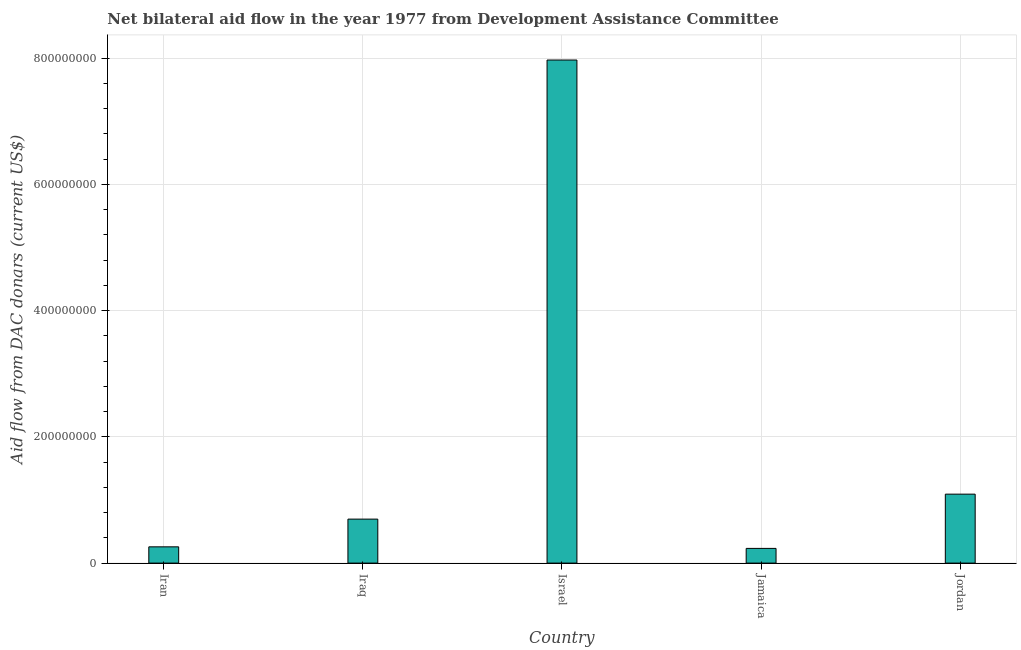Does the graph contain any zero values?
Ensure brevity in your answer.  No. What is the title of the graph?
Your response must be concise. Net bilateral aid flow in the year 1977 from Development Assistance Committee. What is the label or title of the X-axis?
Give a very brief answer. Country. What is the label or title of the Y-axis?
Your answer should be compact. Aid flow from DAC donars (current US$). What is the net bilateral aid flows from dac donors in Iran?
Ensure brevity in your answer.  2.58e+07. Across all countries, what is the maximum net bilateral aid flows from dac donors?
Offer a terse response. 7.97e+08. Across all countries, what is the minimum net bilateral aid flows from dac donors?
Ensure brevity in your answer.  2.33e+07. In which country was the net bilateral aid flows from dac donors maximum?
Offer a terse response. Israel. In which country was the net bilateral aid flows from dac donors minimum?
Provide a short and direct response. Jamaica. What is the sum of the net bilateral aid flows from dac donors?
Make the answer very short. 1.02e+09. What is the difference between the net bilateral aid flows from dac donors in Jamaica and Jordan?
Your answer should be very brief. -8.59e+07. What is the average net bilateral aid flows from dac donors per country?
Offer a terse response. 2.05e+08. What is the median net bilateral aid flows from dac donors?
Provide a succinct answer. 6.97e+07. What is the ratio of the net bilateral aid flows from dac donors in Iraq to that in Jordan?
Provide a short and direct response. 0.64. Is the difference between the net bilateral aid flows from dac donors in Iran and Jamaica greater than the difference between any two countries?
Your answer should be compact. No. What is the difference between the highest and the second highest net bilateral aid flows from dac donors?
Give a very brief answer. 6.88e+08. Is the sum of the net bilateral aid flows from dac donors in Iran and Iraq greater than the maximum net bilateral aid flows from dac donors across all countries?
Provide a short and direct response. No. What is the difference between the highest and the lowest net bilateral aid flows from dac donors?
Keep it short and to the point. 7.74e+08. In how many countries, is the net bilateral aid flows from dac donors greater than the average net bilateral aid flows from dac donors taken over all countries?
Your answer should be very brief. 1. How many countries are there in the graph?
Give a very brief answer. 5. What is the Aid flow from DAC donars (current US$) in Iran?
Make the answer very short. 2.58e+07. What is the Aid flow from DAC donars (current US$) in Iraq?
Your response must be concise. 6.97e+07. What is the Aid flow from DAC donars (current US$) in Israel?
Give a very brief answer. 7.97e+08. What is the Aid flow from DAC donars (current US$) of Jamaica?
Keep it short and to the point. 2.33e+07. What is the Aid flow from DAC donars (current US$) in Jordan?
Your answer should be very brief. 1.09e+08. What is the difference between the Aid flow from DAC donars (current US$) in Iran and Iraq?
Make the answer very short. -4.39e+07. What is the difference between the Aid flow from DAC donars (current US$) in Iran and Israel?
Offer a very short reply. -7.71e+08. What is the difference between the Aid flow from DAC donars (current US$) in Iran and Jamaica?
Make the answer very short. 2.46e+06. What is the difference between the Aid flow from DAC donars (current US$) in Iran and Jordan?
Your response must be concise. -8.35e+07. What is the difference between the Aid flow from DAC donars (current US$) in Iraq and Israel?
Your answer should be compact. -7.27e+08. What is the difference between the Aid flow from DAC donars (current US$) in Iraq and Jamaica?
Ensure brevity in your answer.  4.64e+07. What is the difference between the Aid flow from DAC donars (current US$) in Iraq and Jordan?
Give a very brief answer. -3.96e+07. What is the difference between the Aid flow from DAC donars (current US$) in Israel and Jamaica?
Provide a short and direct response. 7.74e+08. What is the difference between the Aid flow from DAC donars (current US$) in Israel and Jordan?
Ensure brevity in your answer.  6.88e+08. What is the difference between the Aid flow from DAC donars (current US$) in Jamaica and Jordan?
Your answer should be compact. -8.59e+07. What is the ratio of the Aid flow from DAC donars (current US$) in Iran to that in Iraq?
Provide a succinct answer. 0.37. What is the ratio of the Aid flow from DAC donars (current US$) in Iran to that in Israel?
Ensure brevity in your answer.  0.03. What is the ratio of the Aid flow from DAC donars (current US$) in Iran to that in Jamaica?
Give a very brief answer. 1.11. What is the ratio of the Aid flow from DAC donars (current US$) in Iran to that in Jordan?
Offer a terse response. 0.24. What is the ratio of the Aid flow from DAC donars (current US$) in Iraq to that in Israel?
Provide a succinct answer. 0.09. What is the ratio of the Aid flow from DAC donars (current US$) in Iraq to that in Jamaica?
Your answer should be compact. 2.99. What is the ratio of the Aid flow from DAC donars (current US$) in Iraq to that in Jordan?
Give a very brief answer. 0.64. What is the ratio of the Aid flow from DAC donars (current US$) in Israel to that in Jamaica?
Your answer should be very brief. 34.21. What is the ratio of the Aid flow from DAC donars (current US$) in Israel to that in Jordan?
Offer a terse response. 7.3. What is the ratio of the Aid flow from DAC donars (current US$) in Jamaica to that in Jordan?
Your response must be concise. 0.21. 